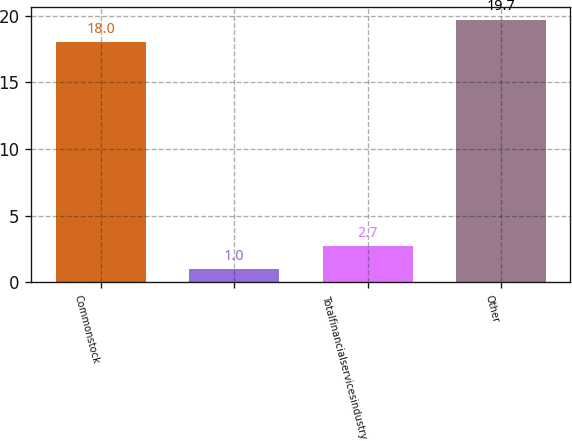<chart> <loc_0><loc_0><loc_500><loc_500><bar_chart><fcel>Commonstock<fcel>Unnamed: 1<fcel>Totalfinancialservicesindustry<fcel>Other<nl><fcel>18<fcel>1<fcel>2.7<fcel>19.7<nl></chart> 